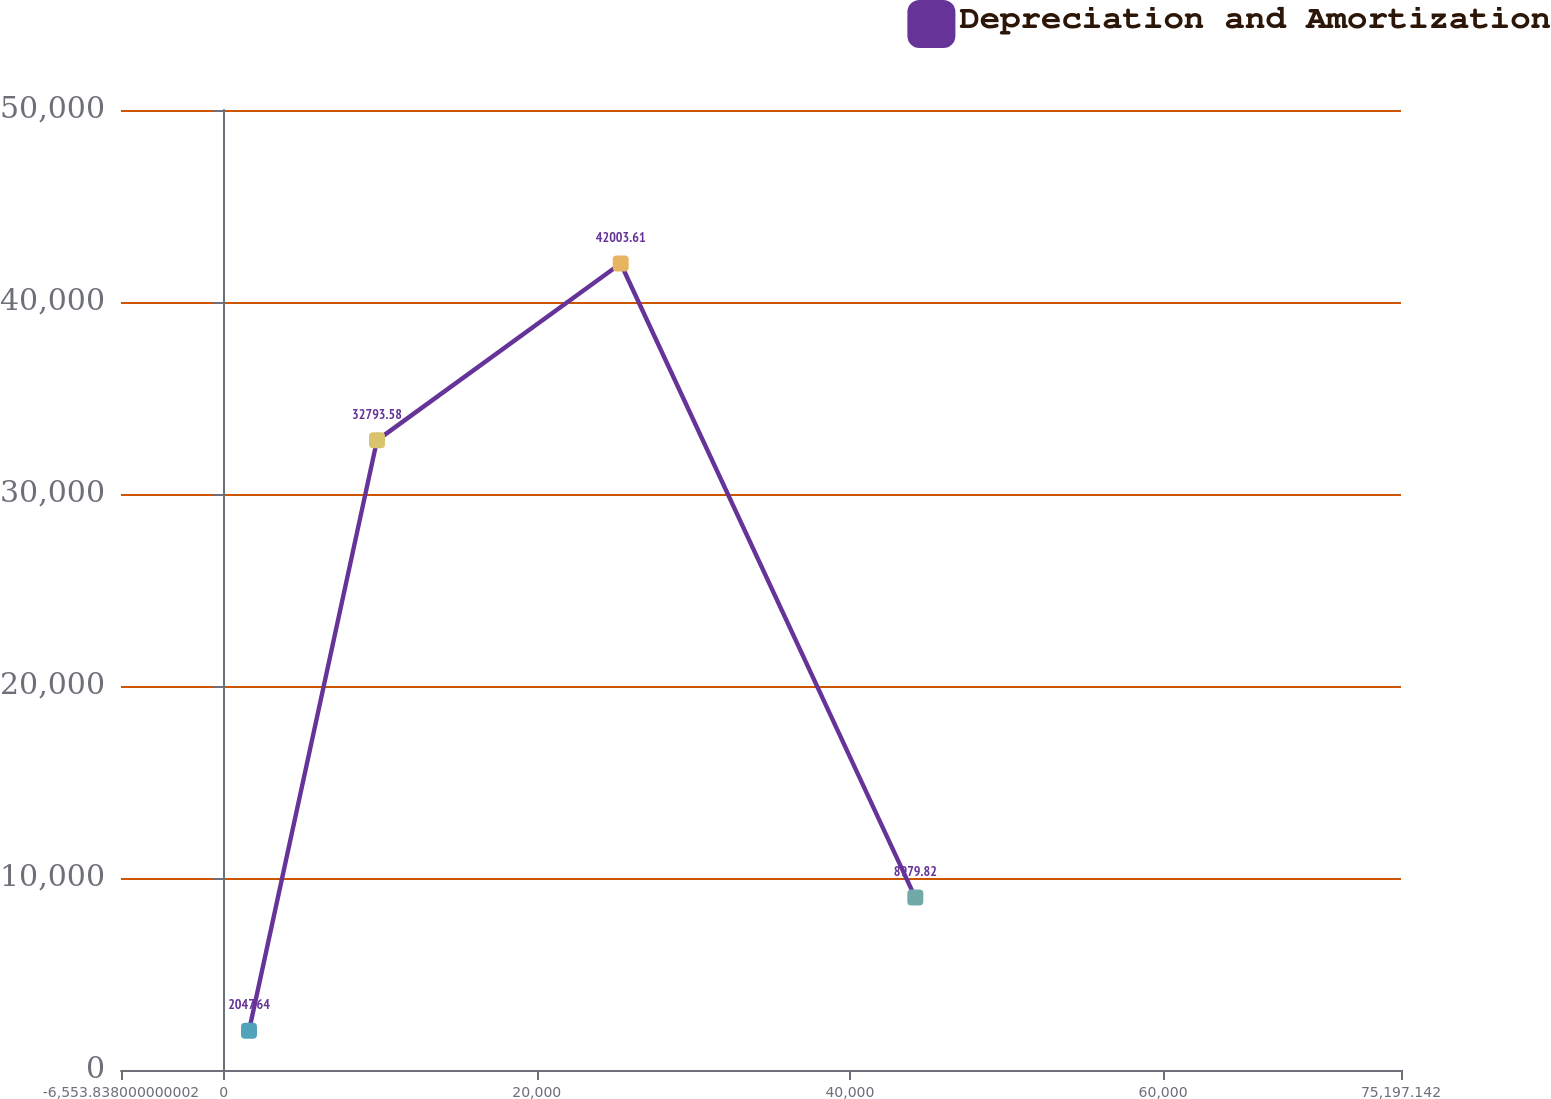Convert chart. <chart><loc_0><loc_0><loc_500><loc_500><line_chart><ecel><fcel>Depreciation and Amortization<nl><fcel>1621.26<fcel>2047.64<nl><fcel>9796.36<fcel>32793.6<nl><fcel>25359.9<fcel>42003.6<nl><fcel>44178.8<fcel>8979.82<nl><fcel>83372.2<fcel>71369.4<nl></chart> 